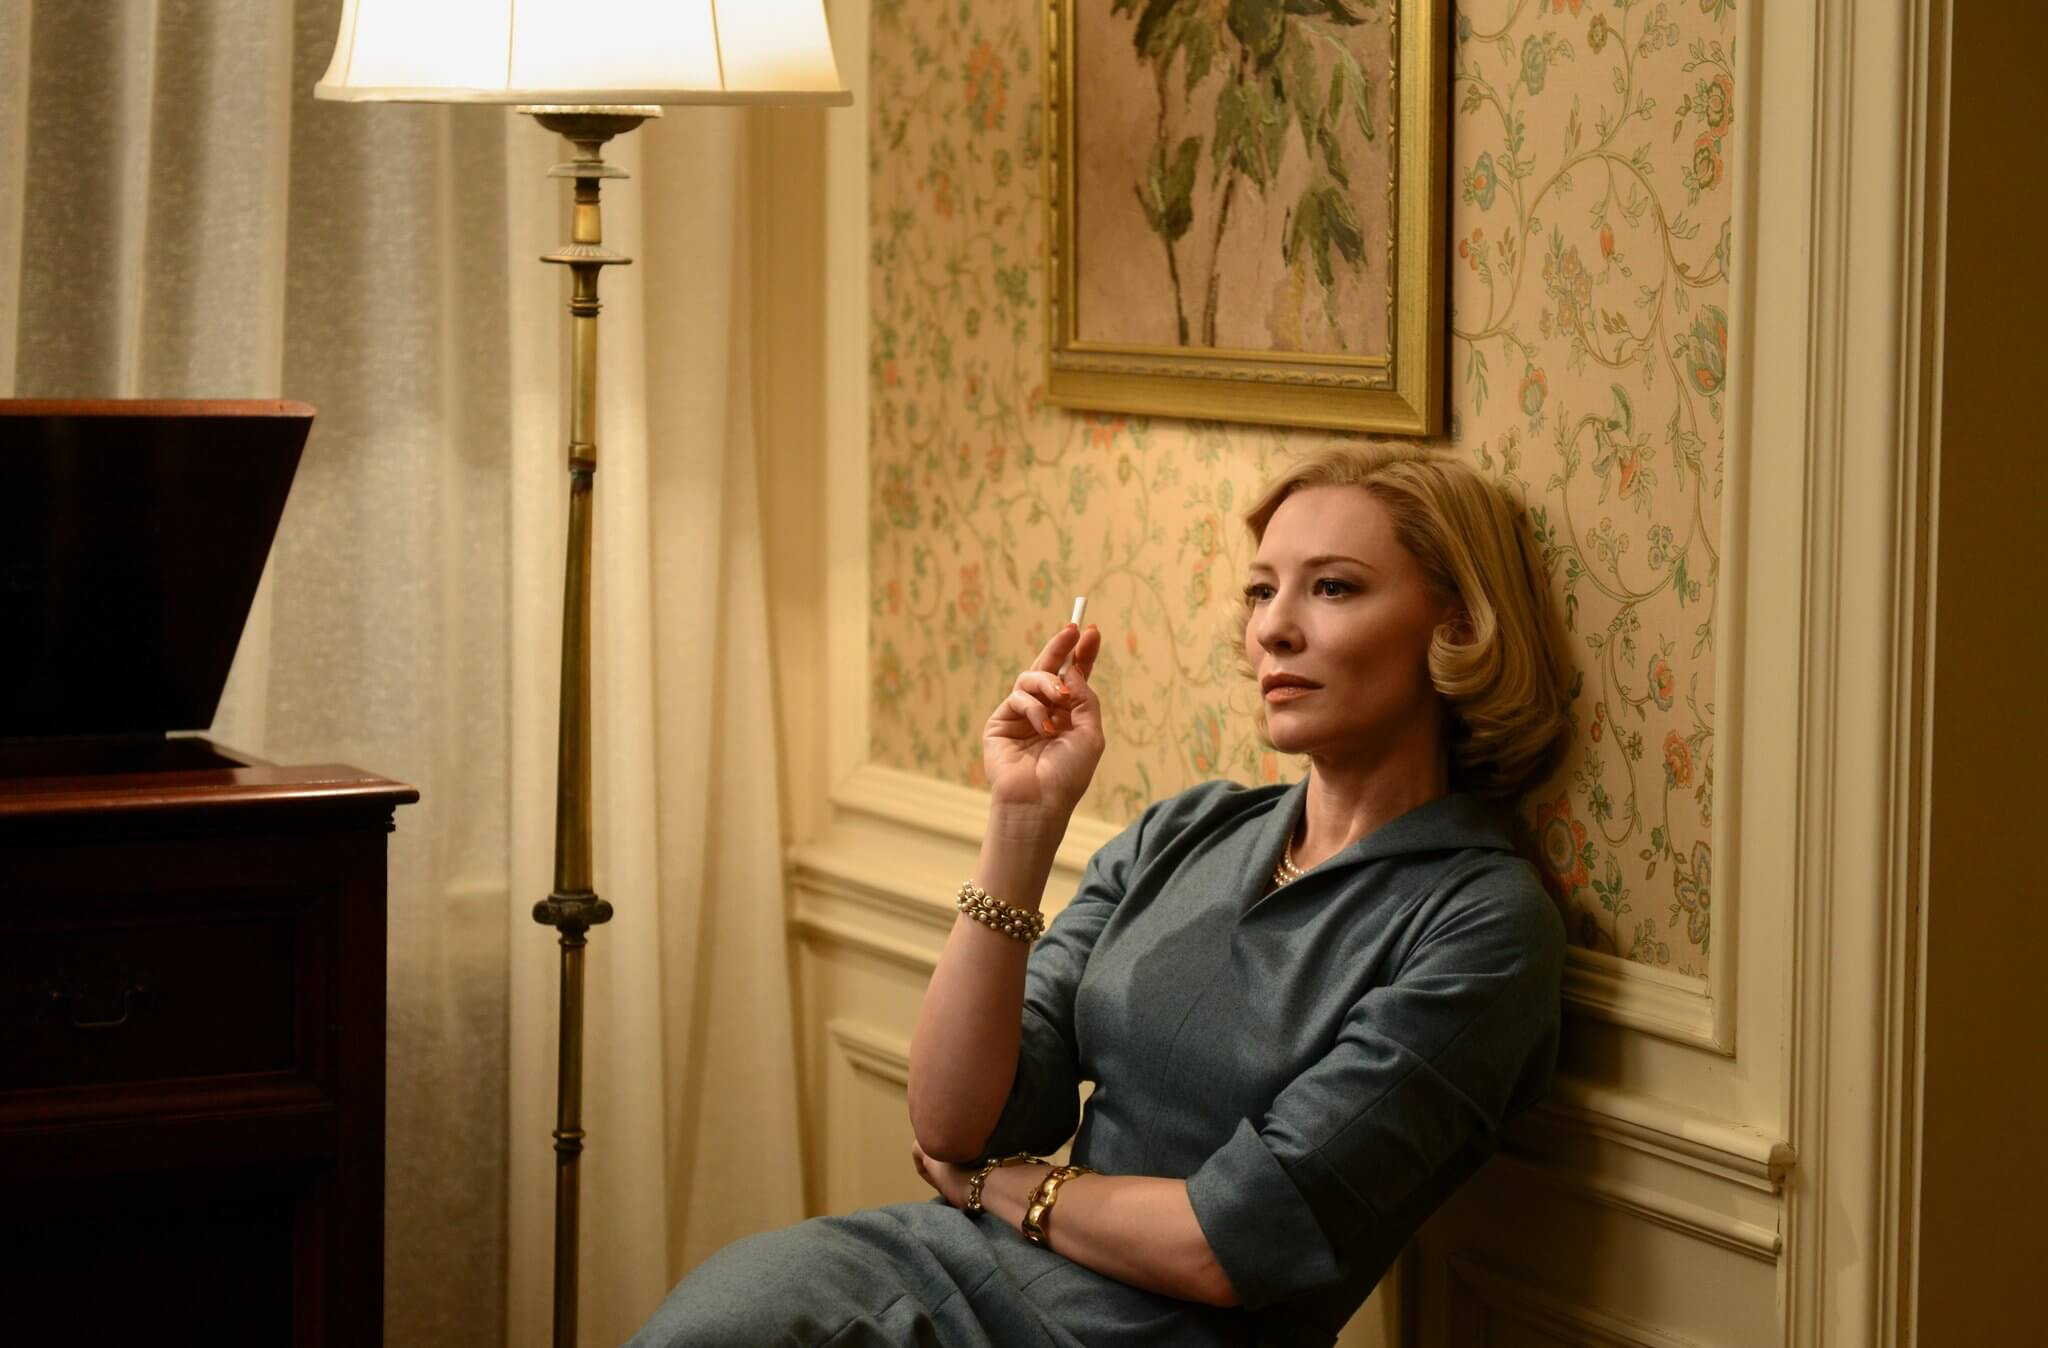What can you infer about the character's mood based on her posture and facial expression? Her posture and facial expression suggest a deep pensiveness or concern. The way she is seated, slightly leaning forward with her arm on the armrest and holding a cigarette, indicates a moment of reflection or anticipation. Her gaze directed away from the viewer implies that she is lost in thought, possibly contemplating significant personal or professional issues. 